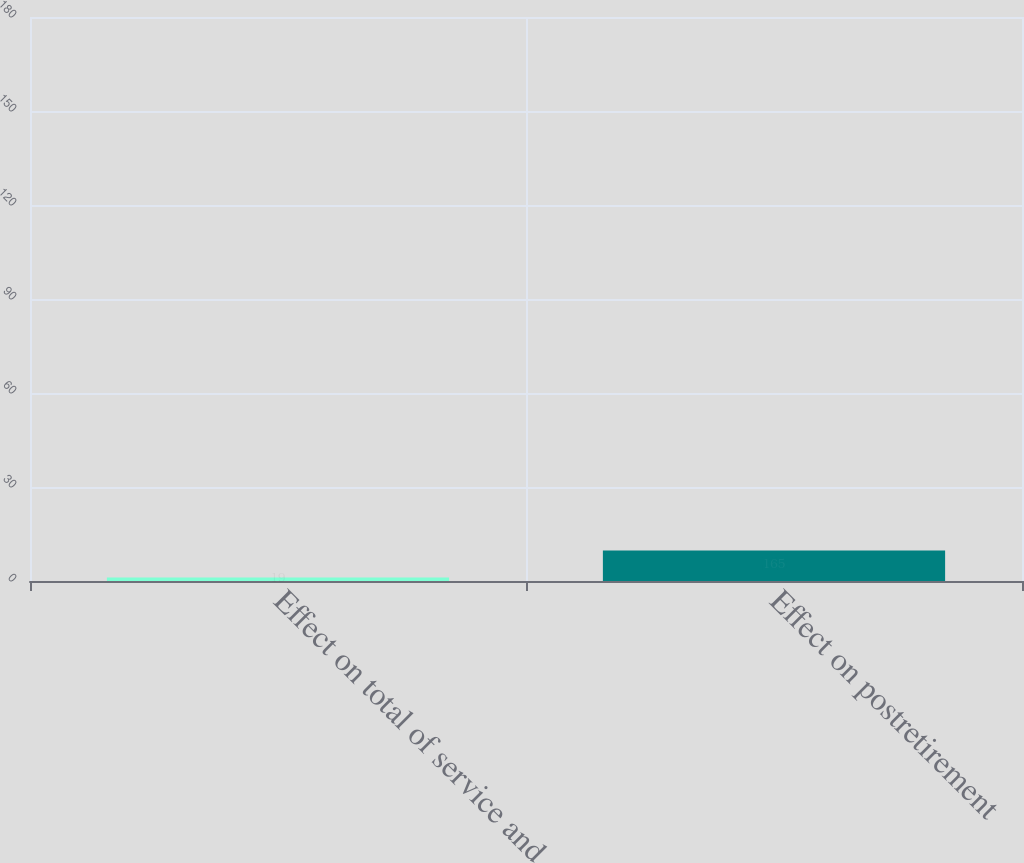<chart> <loc_0><loc_0><loc_500><loc_500><bar_chart><fcel>Effect on total of service and<fcel>Effect on postretirement<nl><fcel>19<fcel>165<nl></chart> 